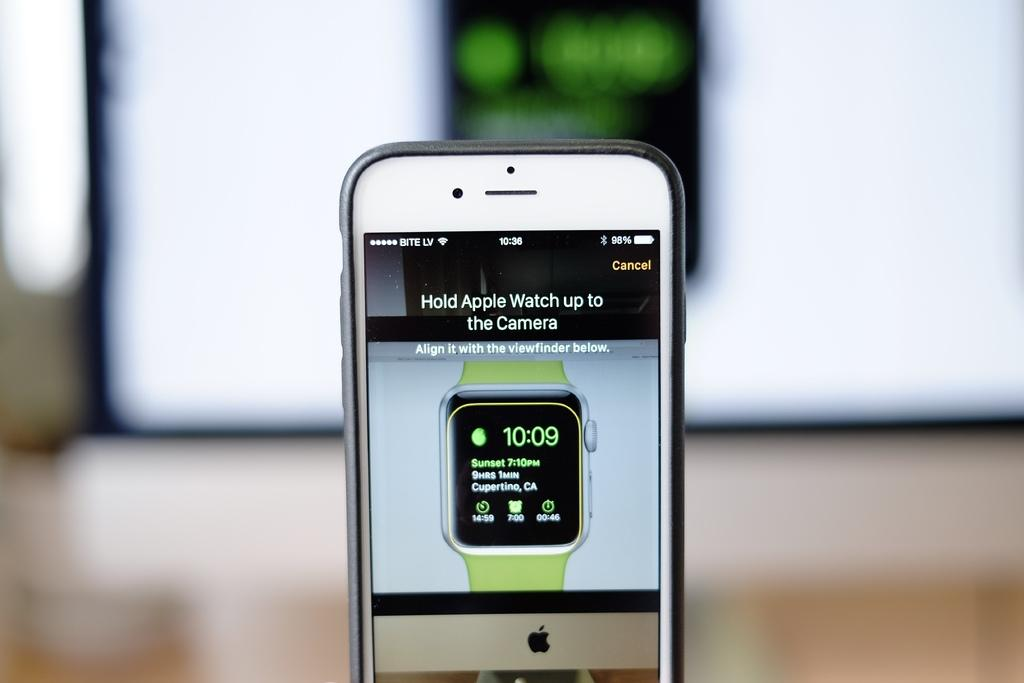Provide a one-sentence caption for the provided image. an Iphone display shows the time as 10:09. 